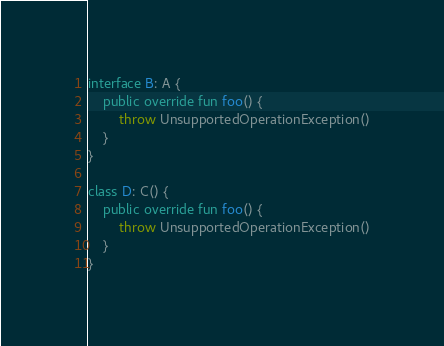<code> <loc_0><loc_0><loc_500><loc_500><_Kotlin_>interface B: A {
    public override fun foo() {
        throw UnsupportedOperationException()
    }
}

class D: C() {
    public override fun foo() {
        throw UnsupportedOperationException()
    }
}</code> 